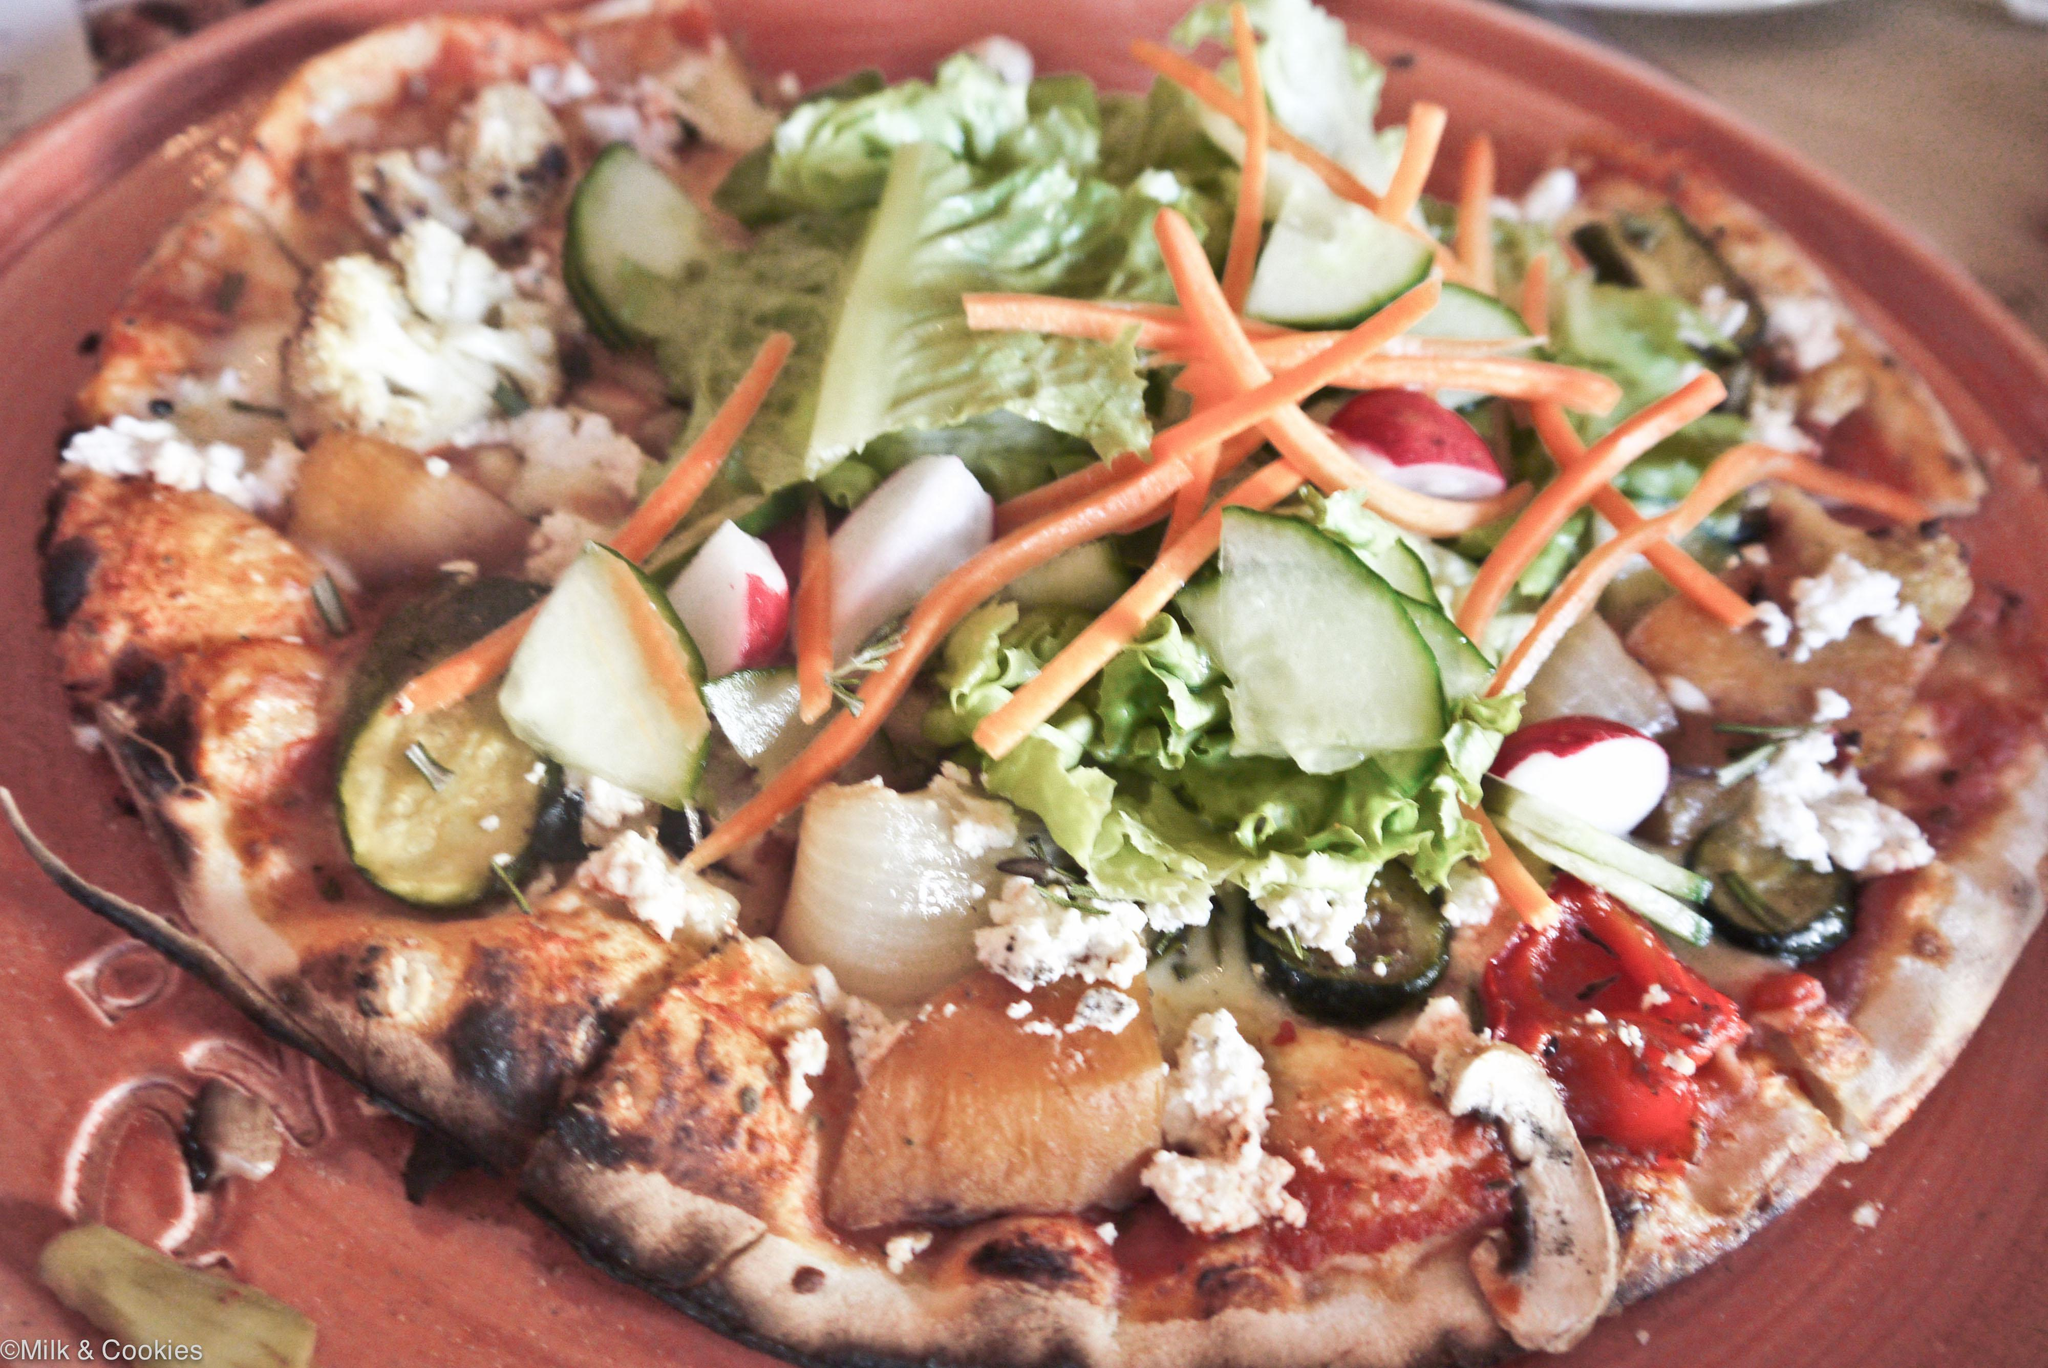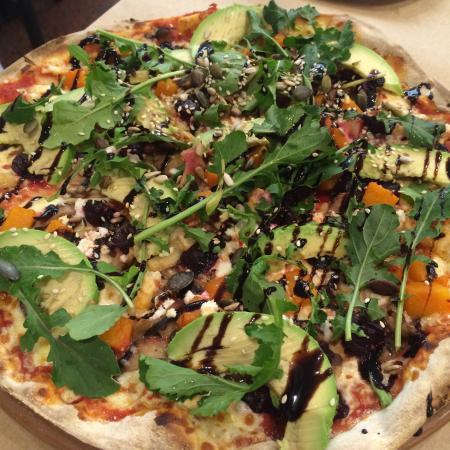The first image is the image on the left, the second image is the image on the right. Evaluate the accuracy of this statement regarding the images: "The left image includes at least two round platters of food and at least one small condiment cup next to a sliced pizza on a brown plank surface.". Is it true? Answer yes or no. No. The first image is the image on the left, the second image is the image on the right. Considering the images on both sides, is "Part of a pizza is missing." valid? Answer yes or no. No. 